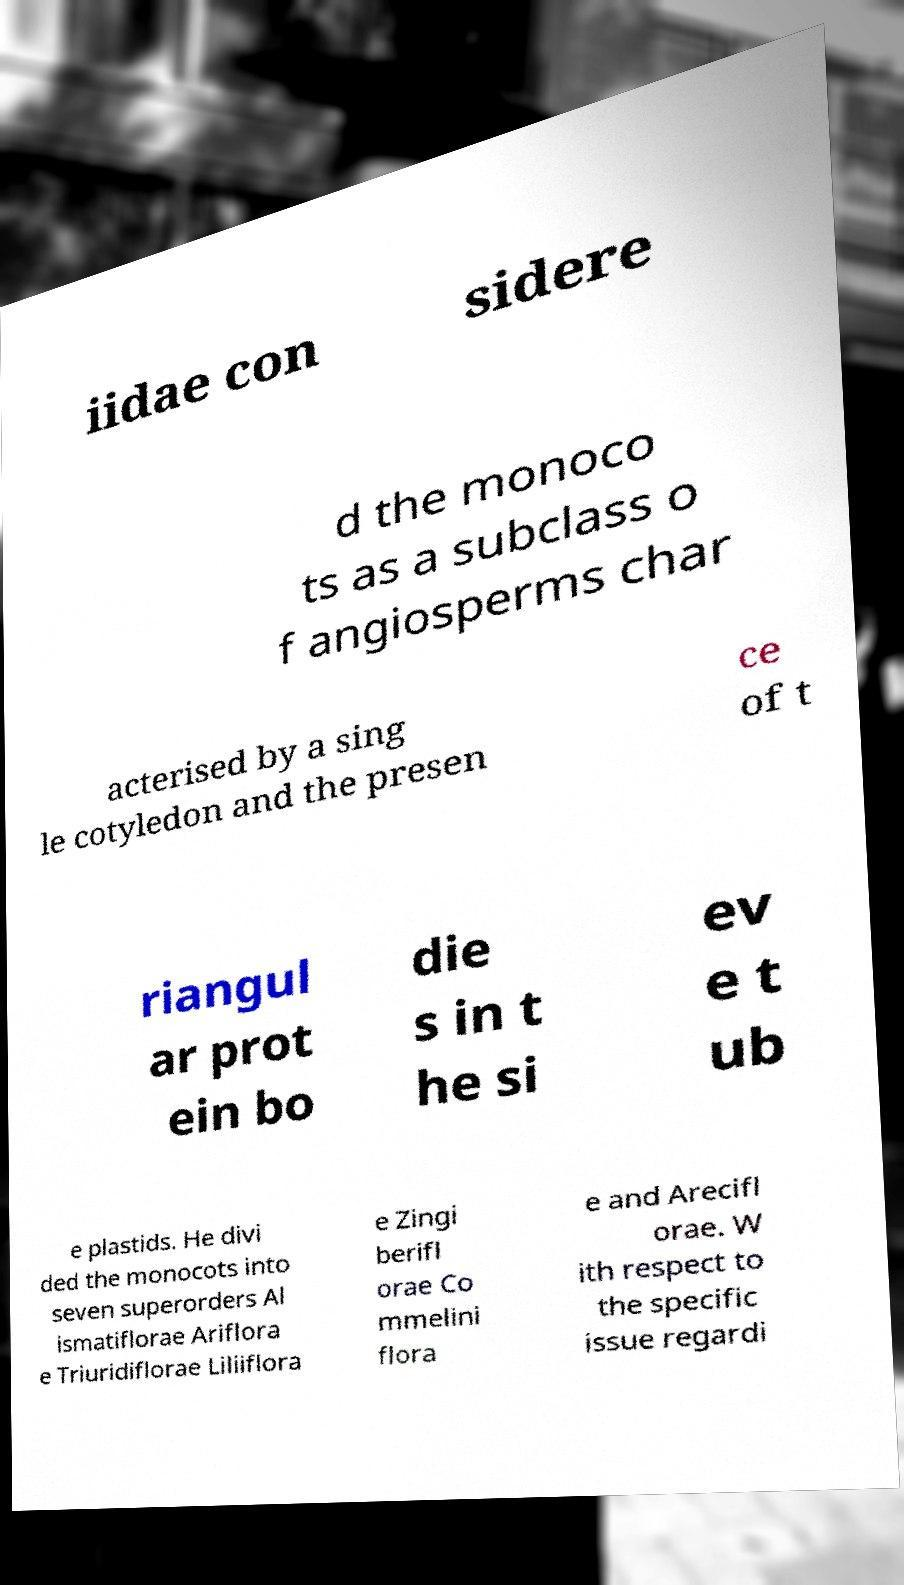What messages or text are displayed in this image? I need them in a readable, typed format. iidae con sidere d the monoco ts as a subclass o f angiosperms char acterised by a sing le cotyledon and the presen ce of t riangul ar prot ein bo die s in t he si ev e t ub e plastids. He divi ded the monocots into seven superorders Al ismatiflorae Ariflora e Triuridiflorae Liliiflora e Zingi berifl orae Co mmelini flora e and Arecifl orae. W ith respect to the specific issue regardi 